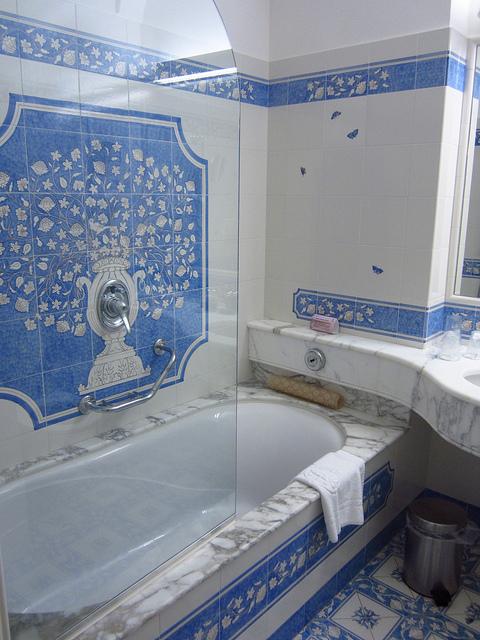Is there a tree in the image?
Answer briefly. Yes. What pattern is in the shower?
Short answer required. Tree. Does this bathtub have a shower also?
Quick response, please. No. 